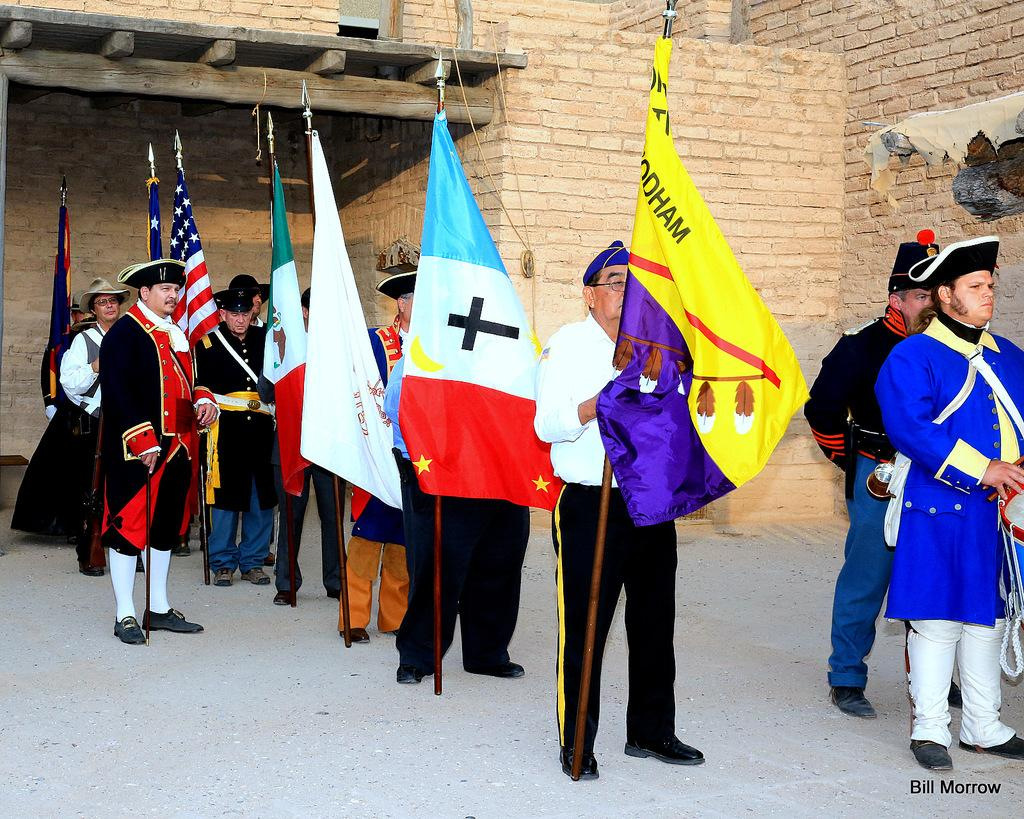What are the people in the image doing? The people in the image are standing on the floor. What are some of the people holding in the image? Some people are holding poles with flags. Can you describe the person on the left side of the image? The person on the left side is holding a stick. What can be seen in the background of the image? There is a wall in the background of the image. What type of bell can be heard ringing in the image? There is no bell present in the image, and therefore no sound can be heard. Can you describe the smiles on the people's faces in the image? The provided facts do not mention any smiles on the people's faces, so we cannot describe them. --- Facts: 1. There is a person sitting on a chair in the image. 2. The person is holding a book. 3. There is a table next to the chair. 4. There is a lamp on the table. 5. The background of the image is a room. Absurd Topics: fish, dance, ocean Conversation: What is the person in the image doing? The person in the image is sitting on a chair. What is the person holding in the image? The person is holding a book. What is located next to the chair in the image? There is a table next to the chair. What is on the table in the image? There is a lamp on the table. What can be seen in the background of the image? The background of the image is a room. Reasoning: Let's think step by step in order to produce the conversation. We start by identifying the main subject in the image, which is the person sitting on a chair. Then, we describe what the person is holding, which is a book. Next, we focus on the objects surrounding the person, such as the table and the lamp. Finally, we describe the background of the image, which is a room. Absurd Question/Answer: How many fish can be seen swimming in the ocean in the image? There is no ocean or fish present in the image. What type of dance is the person performing in the image? The provided facts do not mention any dancing, so we cannot describe a dance being performed. 